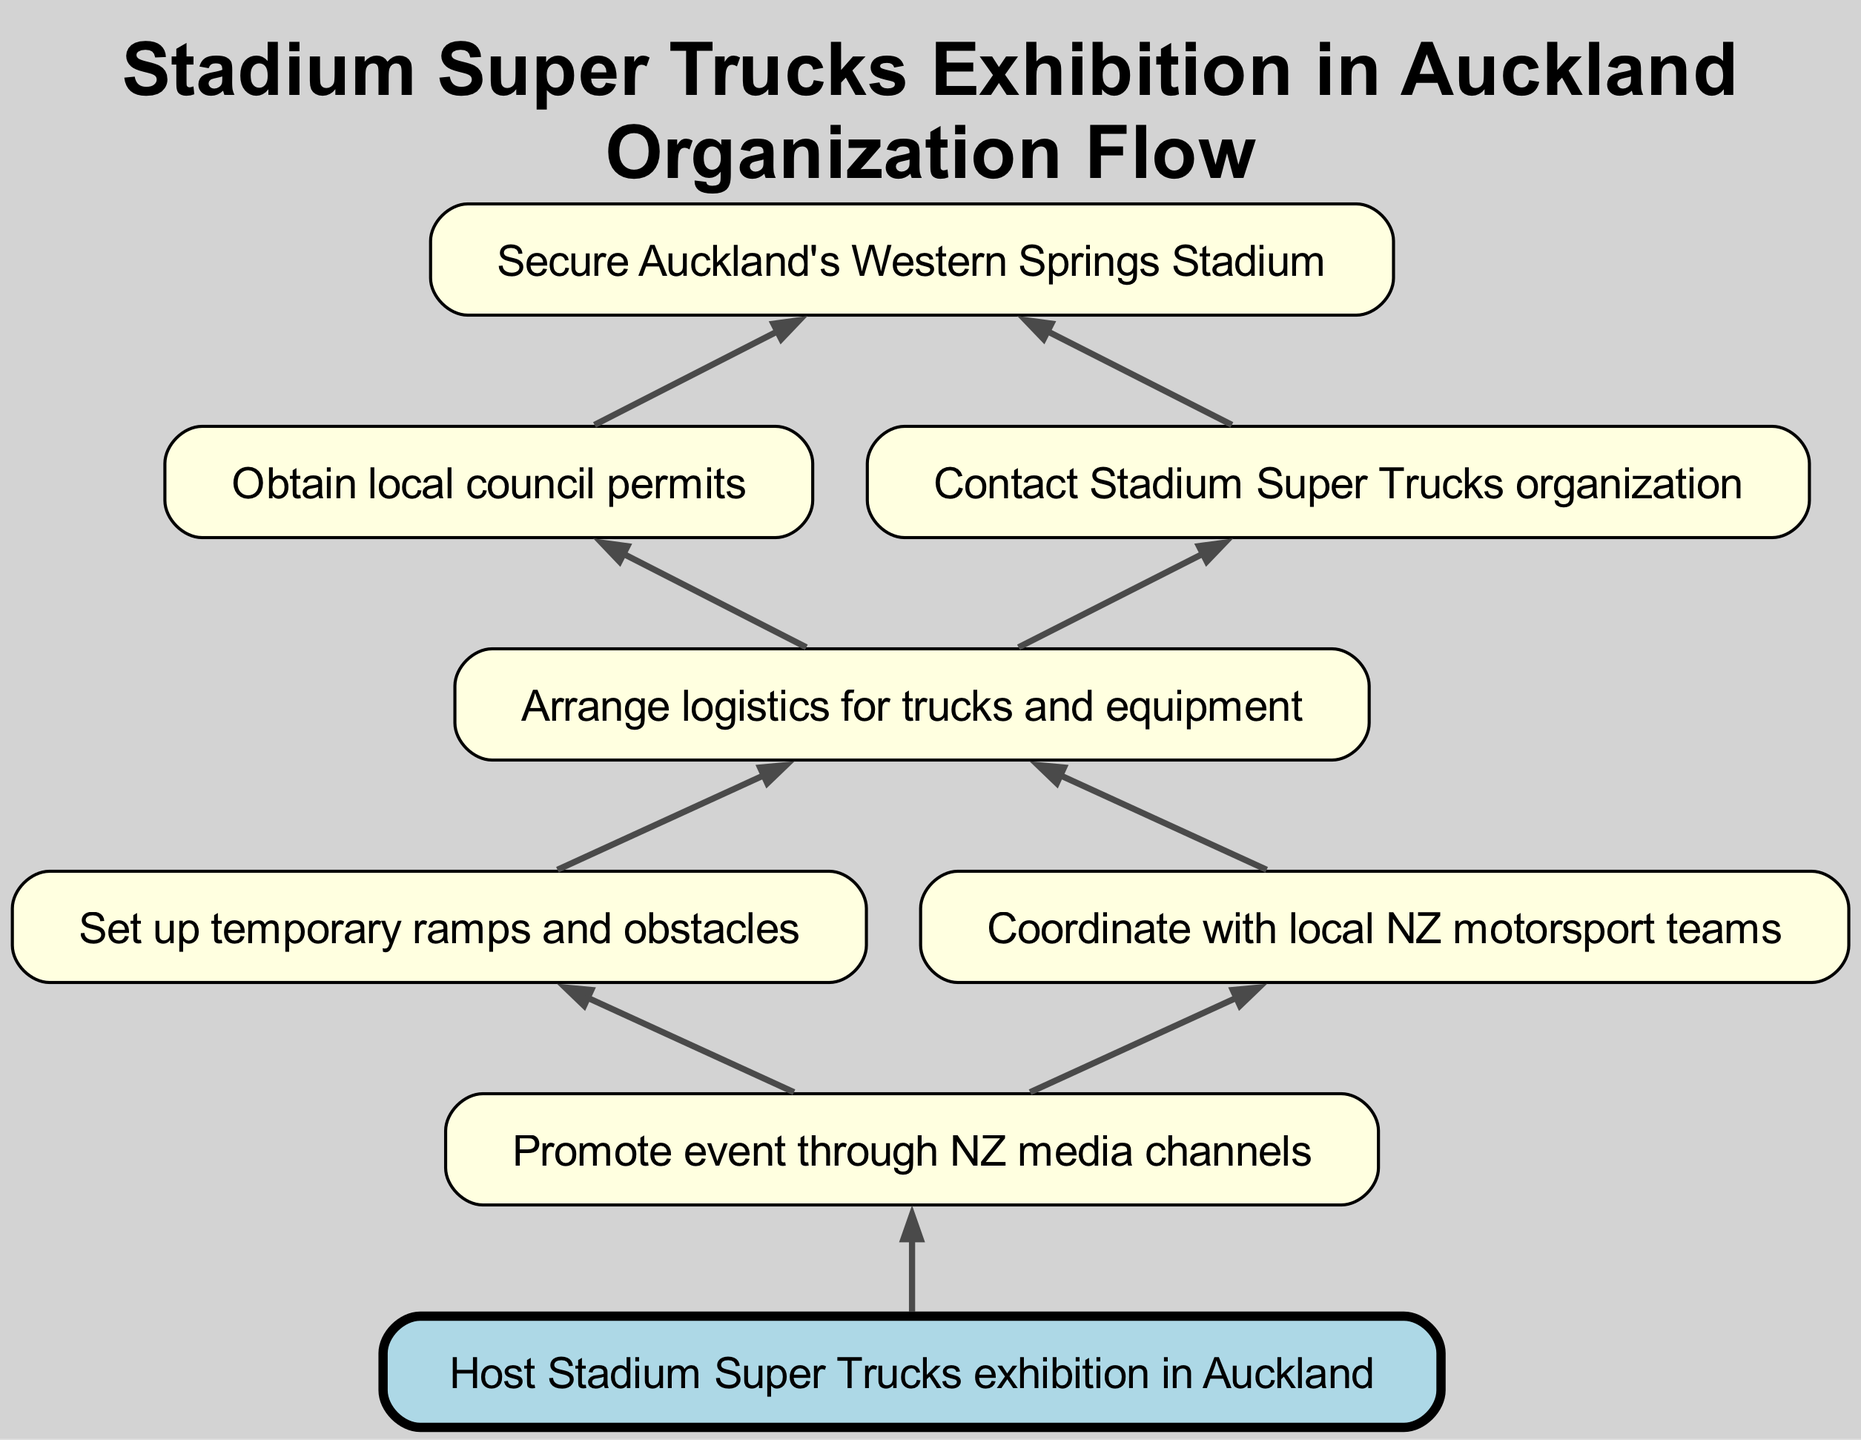What's the first step in organizing the event? The first step in the diagram is "Secure Auckland's Western Springs Stadium," which is depicted as the top node in the flowchart.
Answer: Secure Auckland's Western Springs Stadium How many nodes are present in the diagram? The diagram consists of 8 nodes, each representing a distinct step in the process, as counted visually from the flowchart.
Answer: 8 What step comes after obtaining local council permits? The step that follows "Obtain local council permits" is "Arrange logistics for trucks and equipment," shown as a direct child node connected below it.
Answer: Arrange logistics for trucks and equipment Which node is the final outcome of this process? The final outcome node is "Host Stadium Super Trucks exhibition in Auckland," which does not have any children and is located at the bottom of the flowchart.
Answer: Host Stadium Super Trucks exhibition in Auckland What is the relationship between "Contact Stadium Super Trucks organization" and "Arrange logistics for trucks and equipment"? "Contact Stadium Super Trucks organization" is a prerequisite step necessary to reach "Arrange logistics for trucks and equipment," as they are at the same level with both leading into the logistics arrangement step.
Answer: Prerequisite Which activities are required to be arranged before promoting the event? Before promoting the event, both "Set up temporary ramps and obstacles" and "Coordinate with local NZ motorsport teams" must be arranged, as they feed into the promotion node.
Answer: Set up temporary ramps and obstacles, Coordinate with local NZ motorsport teams What specific aspect of event organization does the child node of "Arrange logistics for trucks and equipment" represent? The two child nodes "Set up temporary ramps and obstacles" and "Coordinate with local NZ motorsport teams" represent specific logistical activities furthering the organization of the event.
Answer: Specific logistical activities How does the bottom-up structure enhance understanding of the event organization? The bottom-up structure clearly illustrates the foundational steps necessary for the overall success of hosting the event, emphasizing that each step is built upon previous actions.
Answer: Clarifies foundational steps 